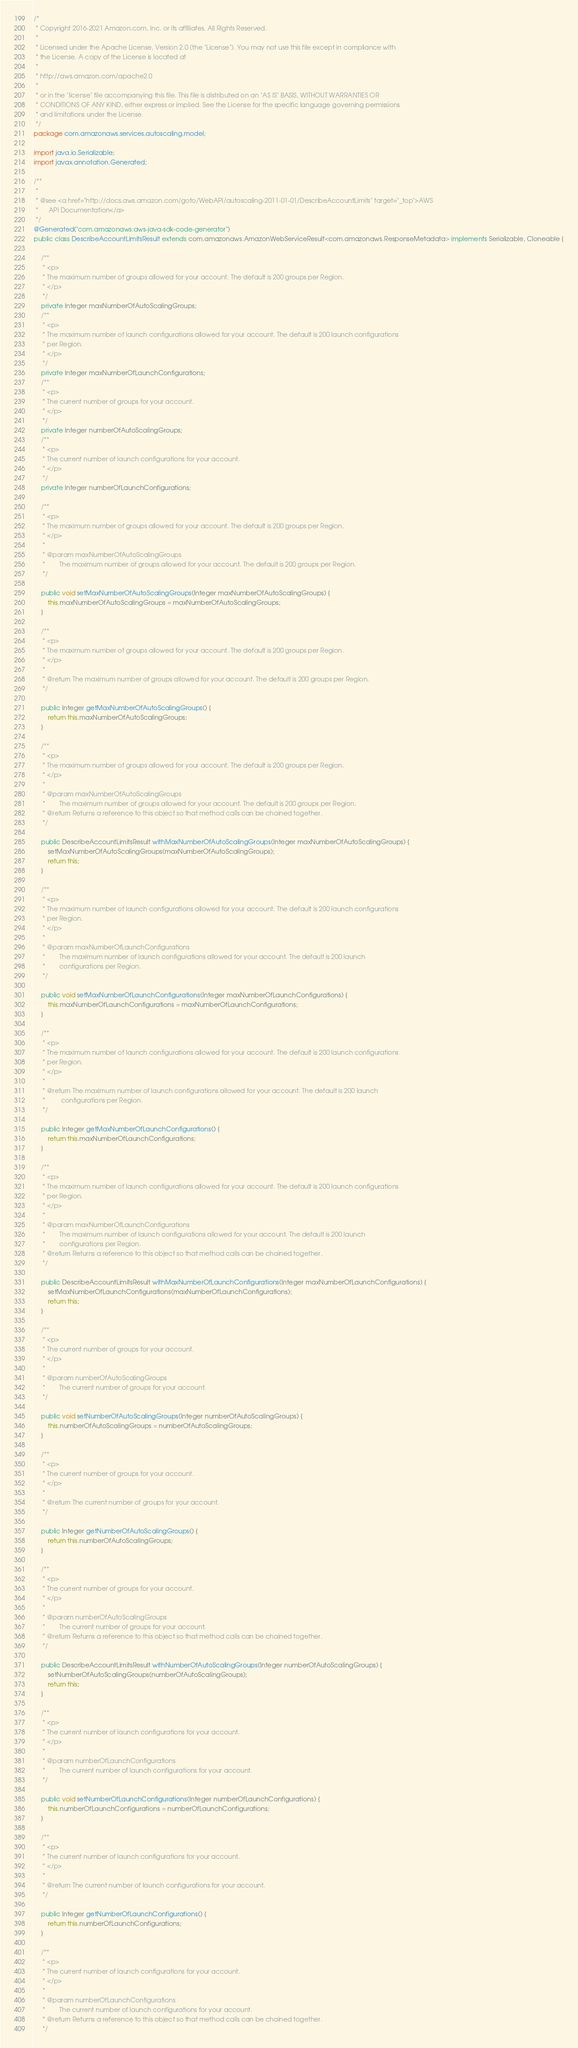<code> <loc_0><loc_0><loc_500><loc_500><_Java_>/*
 * Copyright 2016-2021 Amazon.com, Inc. or its affiliates. All Rights Reserved.
 * 
 * Licensed under the Apache License, Version 2.0 (the "License"). You may not use this file except in compliance with
 * the License. A copy of the License is located at
 * 
 * http://aws.amazon.com/apache2.0
 * 
 * or in the "license" file accompanying this file. This file is distributed on an "AS IS" BASIS, WITHOUT WARRANTIES OR
 * CONDITIONS OF ANY KIND, either express or implied. See the License for the specific language governing permissions
 * and limitations under the License.
 */
package com.amazonaws.services.autoscaling.model;

import java.io.Serializable;
import javax.annotation.Generated;

/**
 * 
 * @see <a href="http://docs.aws.amazon.com/goto/WebAPI/autoscaling-2011-01-01/DescribeAccountLimits" target="_top">AWS
 *      API Documentation</a>
 */
@Generated("com.amazonaws:aws-java-sdk-code-generator")
public class DescribeAccountLimitsResult extends com.amazonaws.AmazonWebServiceResult<com.amazonaws.ResponseMetadata> implements Serializable, Cloneable {

    /**
     * <p>
     * The maximum number of groups allowed for your account. The default is 200 groups per Region.
     * </p>
     */
    private Integer maxNumberOfAutoScalingGroups;
    /**
     * <p>
     * The maximum number of launch configurations allowed for your account. The default is 200 launch configurations
     * per Region.
     * </p>
     */
    private Integer maxNumberOfLaunchConfigurations;
    /**
     * <p>
     * The current number of groups for your account.
     * </p>
     */
    private Integer numberOfAutoScalingGroups;
    /**
     * <p>
     * The current number of launch configurations for your account.
     * </p>
     */
    private Integer numberOfLaunchConfigurations;

    /**
     * <p>
     * The maximum number of groups allowed for your account. The default is 200 groups per Region.
     * </p>
     * 
     * @param maxNumberOfAutoScalingGroups
     *        The maximum number of groups allowed for your account. The default is 200 groups per Region.
     */

    public void setMaxNumberOfAutoScalingGroups(Integer maxNumberOfAutoScalingGroups) {
        this.maxNumberOfAutoScalingGroups = maxNumberOfAutoScalingGroups;
    }

    /**
     * <p>
     * The maximum number of groups allowed for your account. The default is 200 groups per Region.
     * </p>
     * 
     * @return The maximum number of groups allowed for your account. The default is 200 groups per Region.
     */

    public Integer getMaxNumberOfAutoScalingGroups() {
        return this.maxNumberOfAutoScalingGroups;
    }

    /**
     * <p>
     * The maximum number of groups allowed for your account. The default is 200 groups per Region.
     * </p>
     * 
     * @param maxNumberOfAutoScalingGroups
     *        The maximum number of groups allowed for your account. The default is 200 groups per Region.
     * @return Returns a reference to this object so that method calls can be chained together.
     */

    public DescribeAccountLimitsResult withMaxNumberOfAutoScalingGroups(Integer maxNumberOfAutoScalingGroups) {
        setMaxNumberOfAutoScalingGroups(maxNumberOfAutoScalingGroups);
        return this;
    }

    /**
     * <p>
     * The maximum number of launch configurations allowed for your account. The default is 200 launch configurations
     * per Region.
     * </p>
     * 
     * @param maxNumberOfLaunchConfigurations
     *        The maximum number of launch configurations allowed for your account. The default is 200 launch
     *        configurations per Region.
     */

    public void setMaxNumberOfLaunchConfigurations(Integer maxNumberOfLaunchConfigurations) {
        this.maxNumberOfLaunchConfigurations = maxNumberOfLaunchConfigurations;
    }

    /**
     * <p>
     * The maximum number of launch configurations allowed for your account. The default is 200 launch configurations
     * per Region.
     * </p>
     * 
     * @return The maximum number of launch configurations allowed for your account. The default is 200 launch
     *         configurations per Region.
     */

    public Integer getMaxNumberOfLaunchConfigurations() {
        return this.maxNumberOfLaunchConfigurations;
    }

    /**
     * <p>
     * The maximum number of launch configurations allowed for your account. The default is 200 launch configurations
     * per Region.
     * </p>
     * 
     * @param maxNumberOfLaunchConfigurations
     *        The maximum number of launch configurations allowed for your account. The default is 200 launch
     *        configurations per Region.
     * @return Returns a reference to this object so that method calls can be chained together.
     */

    public DescribeAccountLimitsResult withMaxNumberOfLaunchConfigurations(Integer maxNumberOfLaunchConfigurations) {
        setMaxNumberOfLaunchConfigurations(maxNumberOfLaunchConfigurations);
        return this;
    }

    /**
     * <p>
     * The current number of groups for your account.
     * </p>
     * 
     * @param numberOfAutoScalingGroups
     *        The current number of groups for your account.
     */

    public void setNumberOfAutoScalingGroups(Integer numberOfAutoScalingGroups) {
        this.numberOfAutoScalingGroups = numberOfAutoScalingGroups;
    }

    /**
     * <p>
     * The current number of groups for your account.
     * </p>
     * 
     * @return The current number of groups for your account.
     */

    public Integer getNumberOfAutoScalingGroups() {
        return this.numberOfAutoScalingGroups;
    }

    /**
     * <p>
     * The current number of groups for your account.
     * </p>
     * 
     * @param numberOfAutoScalingGroups
     *        The current number of groups for your account.
     * @return Returns a reference to this object so that method calls can be chained together.
     */

    public DescribeAccountLimitsResult withNumberOfAutoScalingGroups(Integer numberOfAutoScalingGroups) {
        setNumberOfAutoScalingGroups(numberOfAutoScalingGroups);
        return this;
    }

    /**
     * <p>
     * The current number of launch configurations for your account.
     * </p>
     * 
     * @param numberOfLaunchConfigurations
     *        The current number of launch configurations for your account.
     */

    public void setNumberOfLaunchConfigurations(Integer numberOfLaunchConfigurations) {
        this.numberOfLaunchConfigurations = numberOfLaunchConfigurations;
    }

    /**
     * <p>
     * The current number of launch configurations for your account.
     * </p>
     * 
     * @return The current number of launch configurations for your account.
     */

    public Integer getNumberOfLaunchConfigurations() {
        return this.numberOfLaunchConfigurations;
    }

    /**
     * <p>
     * The current number of launch configurations for your account.
     * </p>
     * 
     * @param numberOfLaunchConfigurations
     *        The current number of launch configurations for your account.
     * @return Returns a reference to this object so that method calls can be chained together.
     */
</code> 